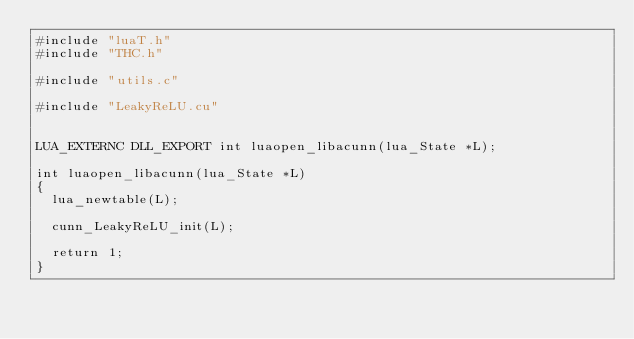<code> <loc_0><loc_0><loc_500><loc_500><_Cuda_>#include "luaT.h"
#include "THC.h"

#include "utils.c"

#include "LeakyReLU.cu"


LUA_EXTERNC DLL_EXPORT int luaopen_libacunn(lua_State *L);

int luaopen_libacunn(lua_State *L)
{
  lua_newtable(L);

  cunn_LeakyReLU_init(L);

  return 1;
}
</code> 